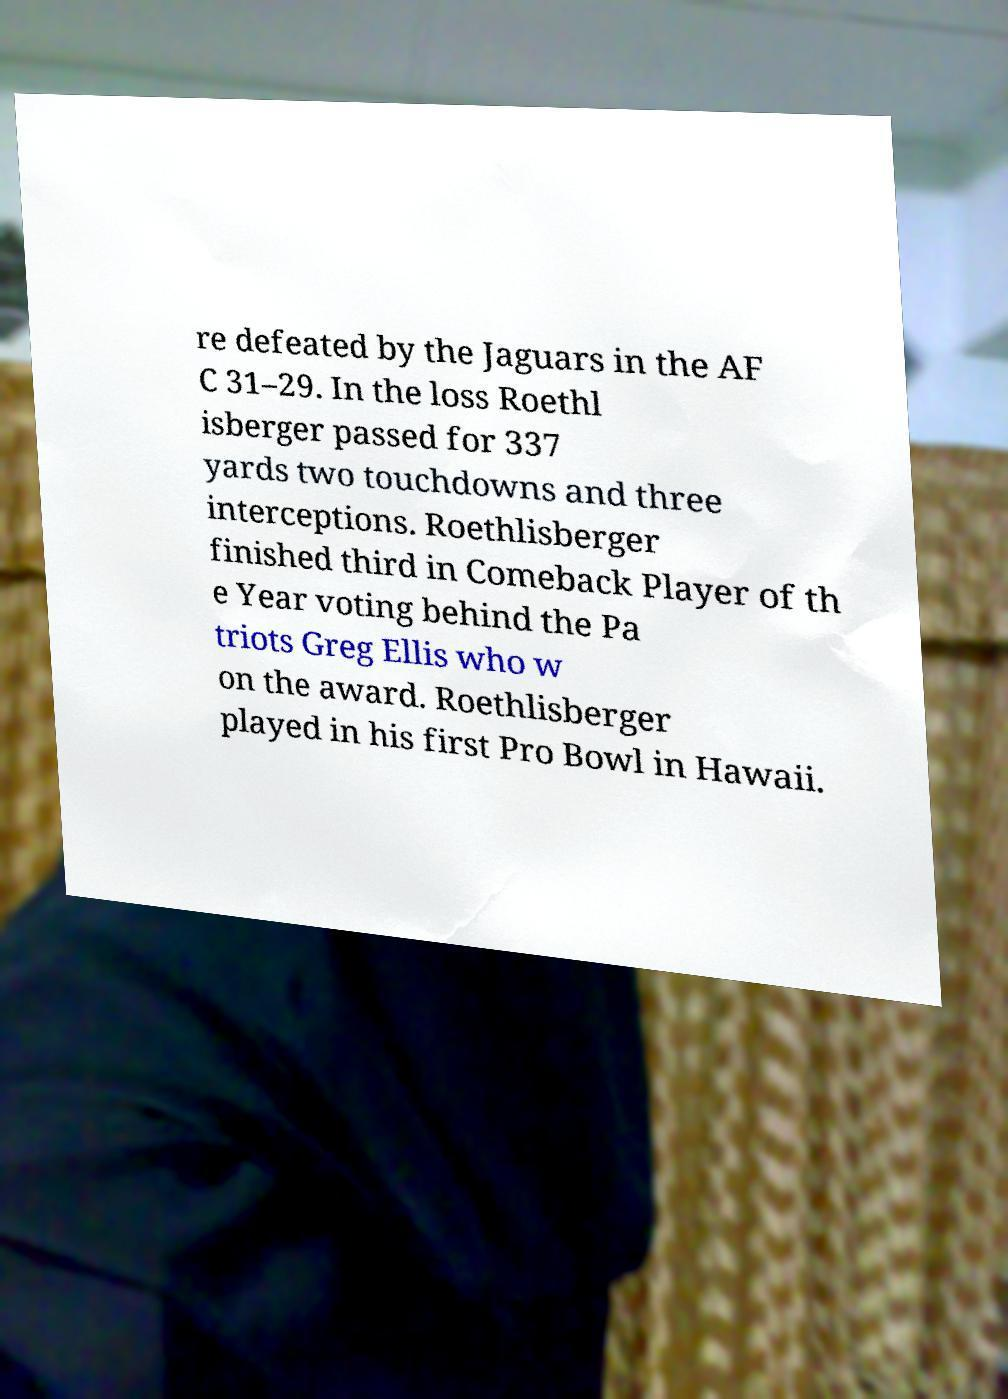Could you assist in decoding the text presented in this image and type it out clearly? re defeated by the Jaguars in the AF C 31–29. In the loss Roethl isberger passed for 337 yards two touchdowns and three interceptions. Roethlisberger finished third in Comeback Player of th e Year voting behind the Pa triots Greg Ellis who w on the award. Roethlisberger played in his first Pro Bowl in Hawaii. 